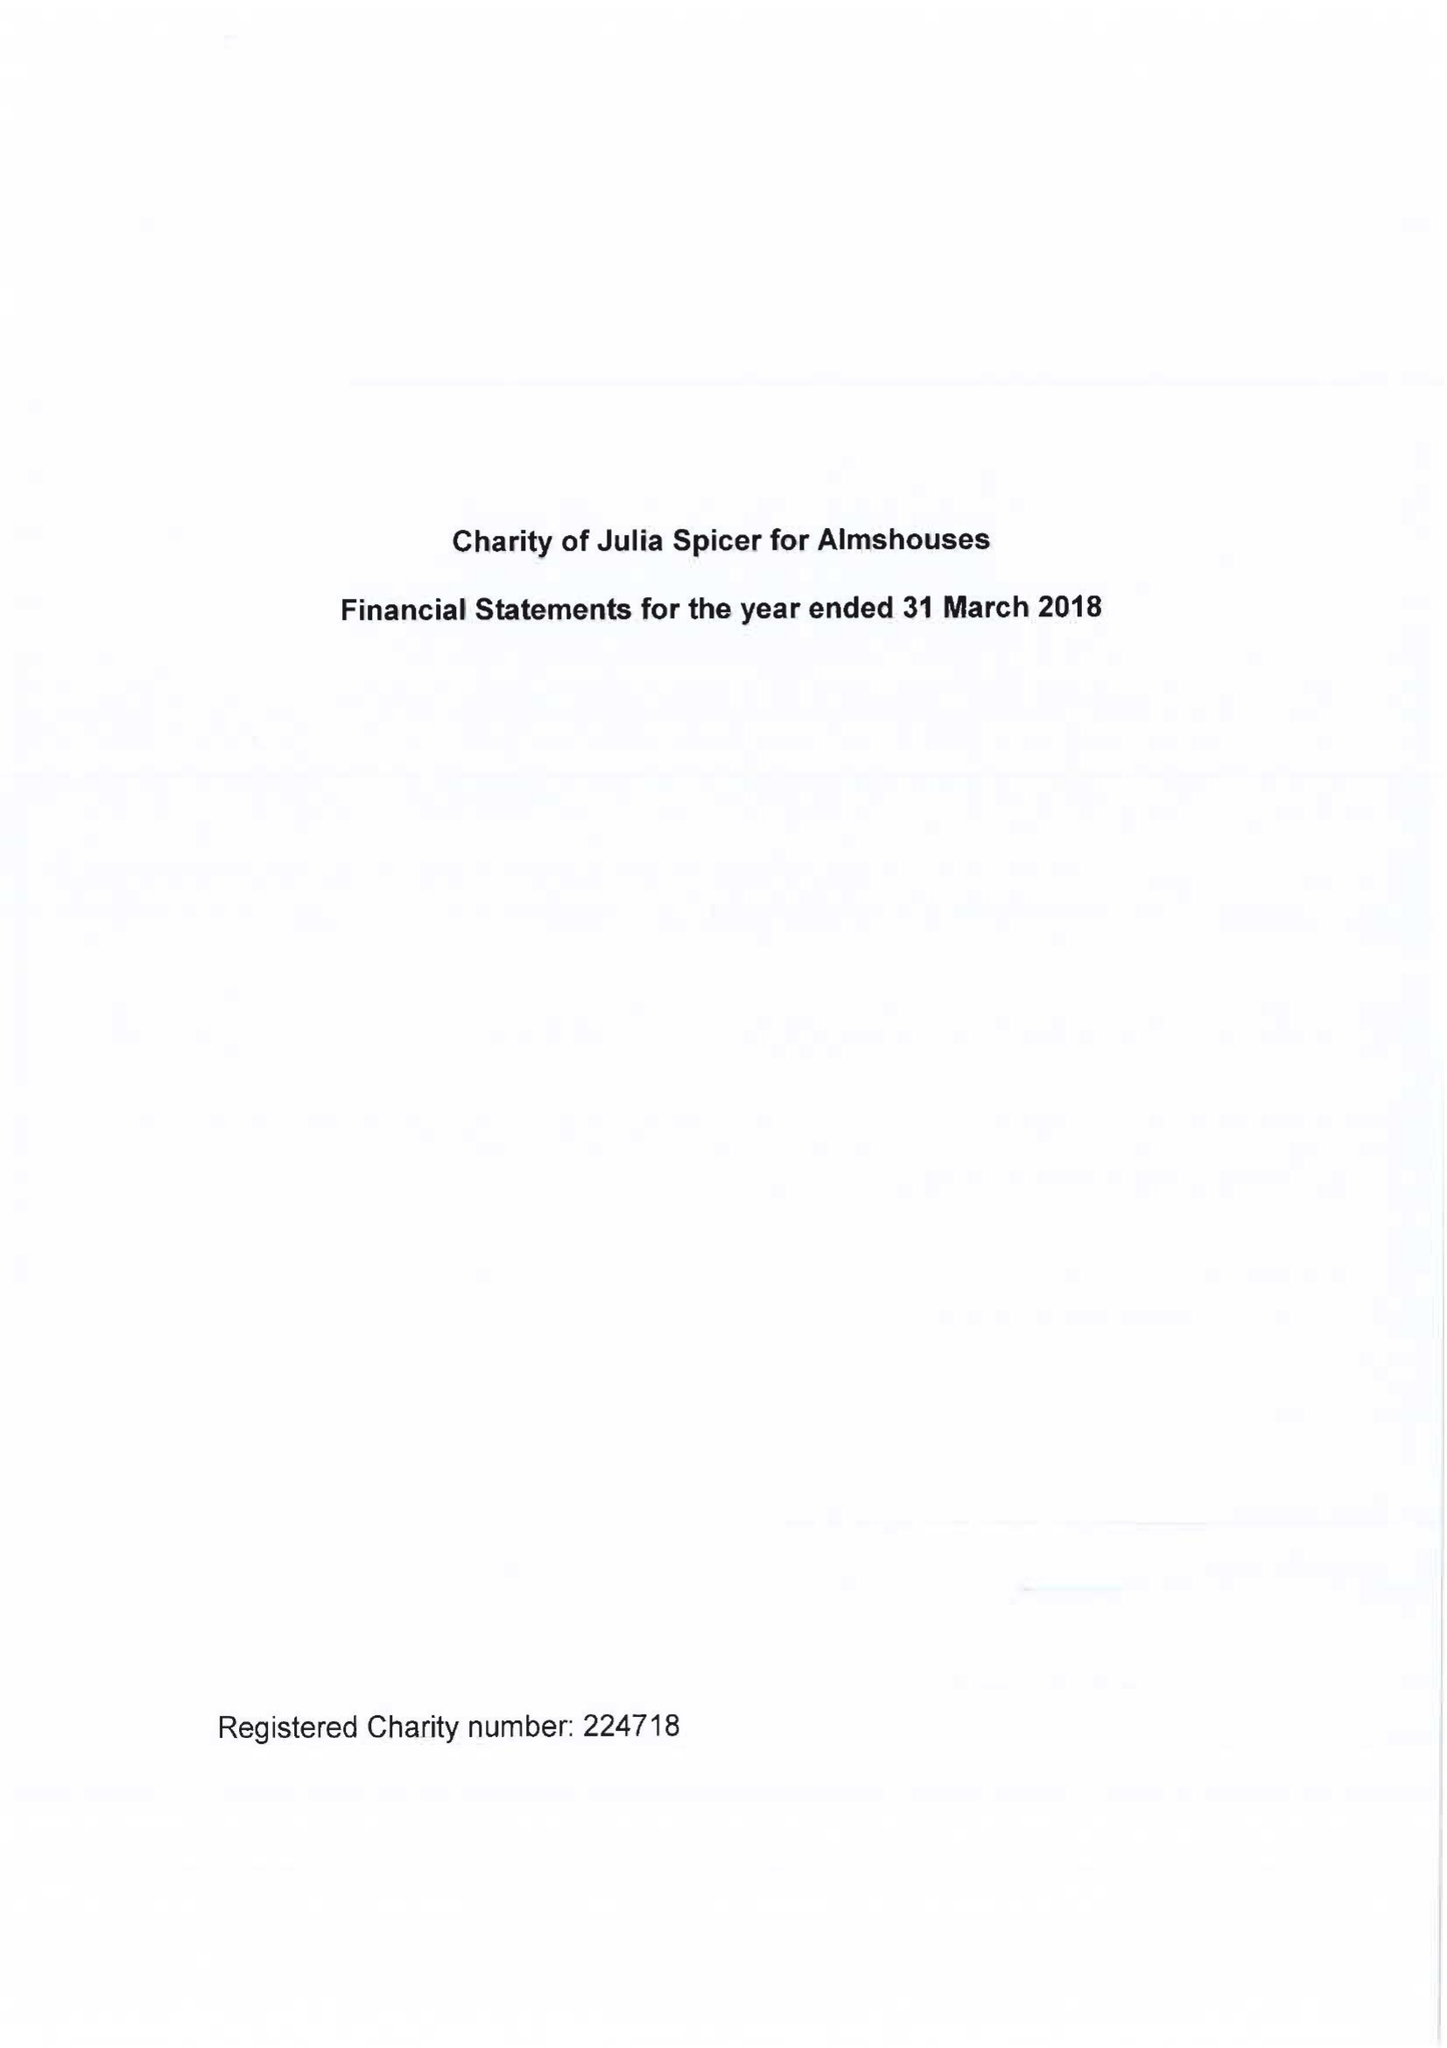What is the value for the income_annually_in_british_pounds?
Answer the question using a single word or phrase. 67462.00 